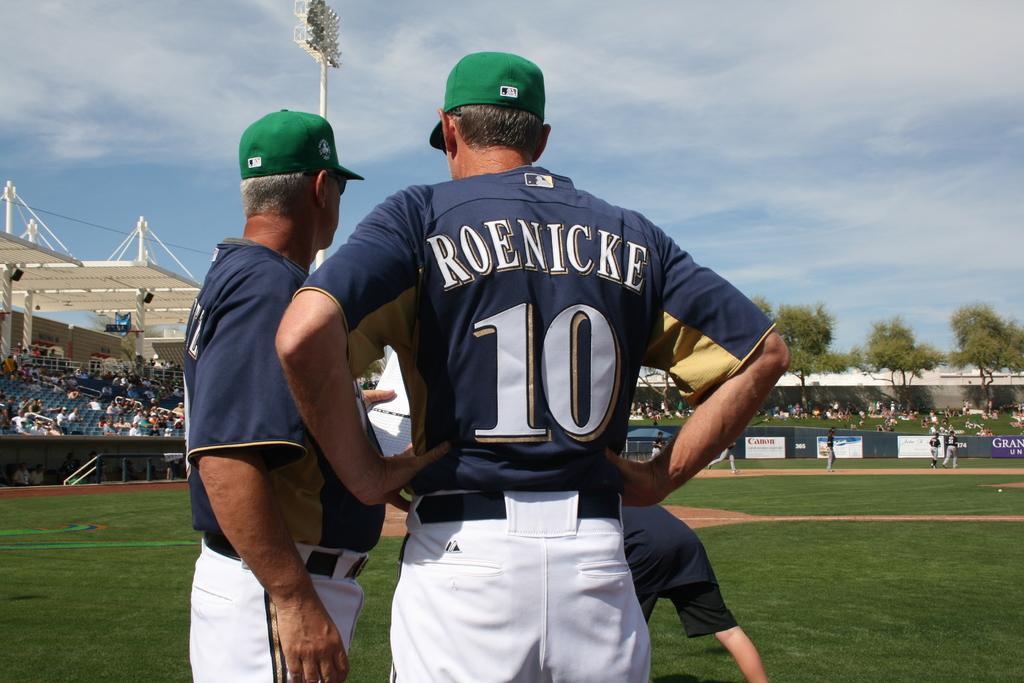In one or two sentences, can you explain what this image depicts? In this picture there is a man who is wearing number ten Jersey, cap and trouser. Beside him there is a another man who is wearing goggles, cap, t-shirt and trouser. In front of them there is a man who is holding the papers. Beside him I can see the man who is wearing blue dress and standing on the grass. On the right background I can see some players were running on the ground. In the background I can see many peoples were sitting and standing near the trees and wall. On the left I can see the stadium, beside that there is a pole. On the pole I can see many focus lights. At the top right I can see the sky and clouds. 